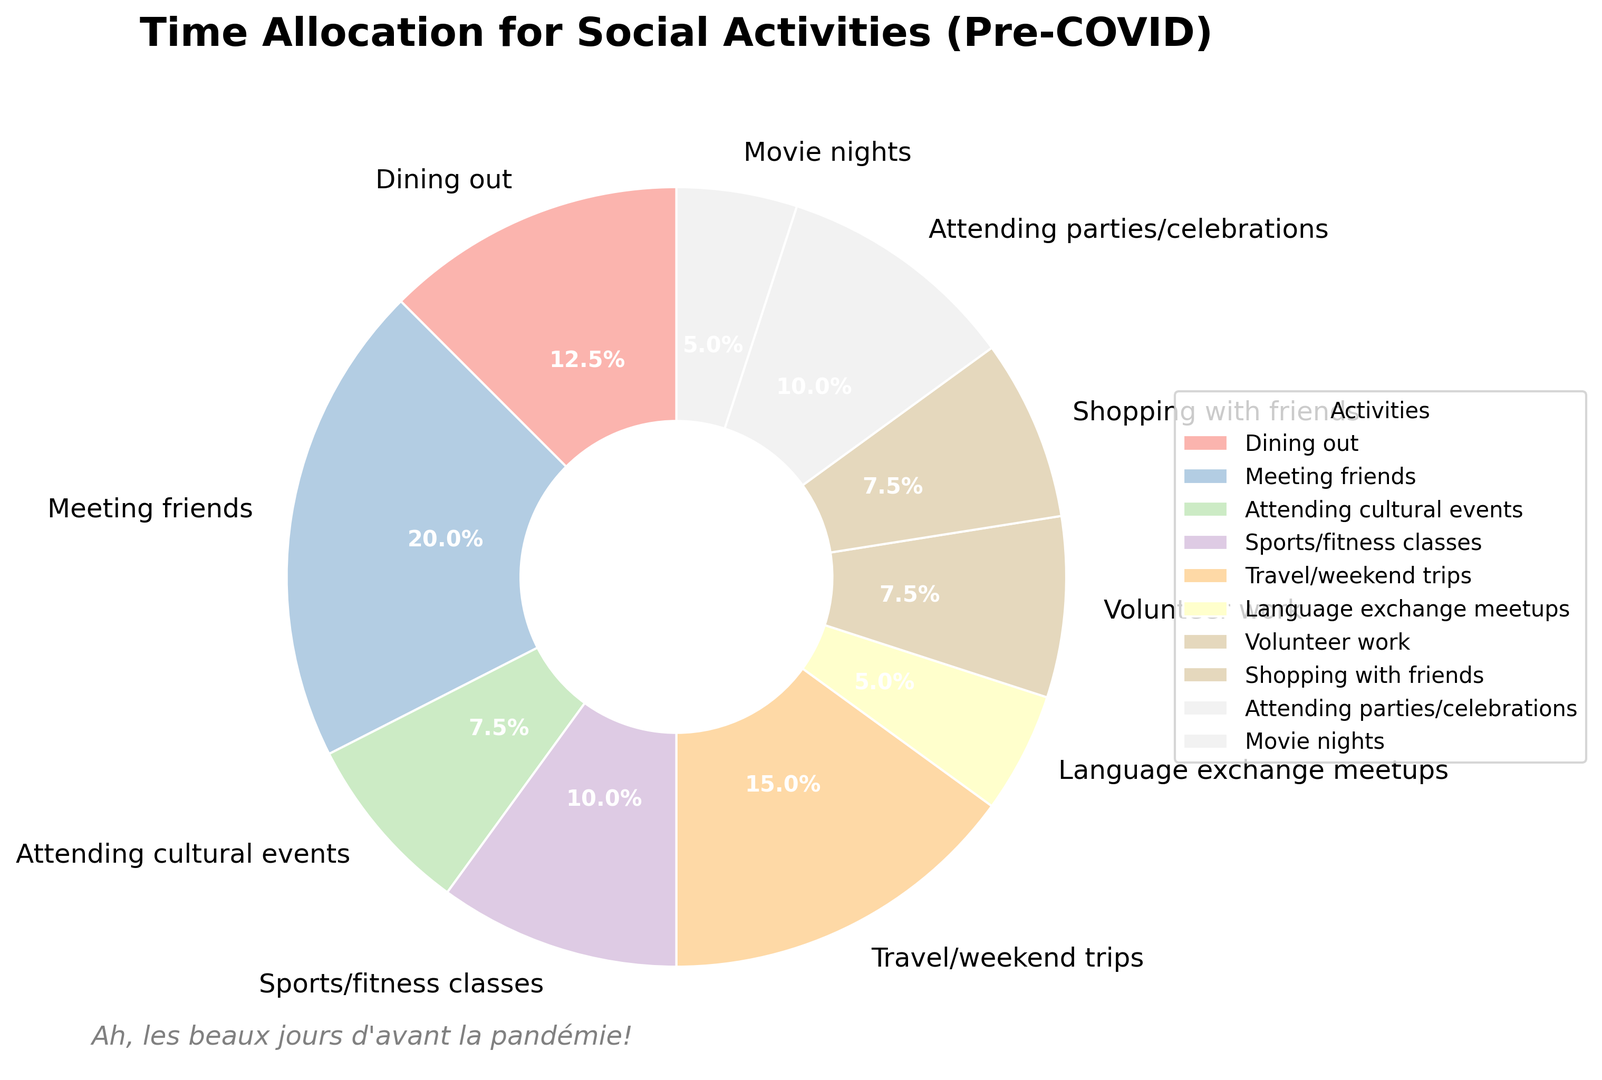Which activity occupies the highest percentage of time? To determine the activity with the highest percentage, locate the segment with the largest area on the pie chart. The segment labeled "Meeting friends" occupies the largest area.
Answer: Meeting friends What is the combined percentage of time spent on attending cultural events and volunteer work? First, find the percentage of each activity from the pie chart. Then add the two percentages together. Attending cultural events and volunteer work are each labeled with their percentages, which are both 6%. Adding these gives 6% + 6% = 12%.
Answer: 12% Is more time allocated to travel/weekend trips or attending parties/celebrations? Compare the percentages shown for travel/weekend trips and attending parties/celebrations. Travel/weekend trips have a larger area and thus represent a higher percentage.
Answer: Travel/weekend trips Which activities take up exactly the same amount of time per week? Look for segments on the pie chart with identical percentages labeled. Attending cultural events, volunteer work, and shopping with friends each have 6% of the pie, indicating they take up the same amount of time.
Answer: Attending cultural events, volunteer work, shopping with friends What is the total number of hours spent on fitness-related and dining-out activities combined? Find the individual hours per week for sports/fitness classes (4 hours) and dining out (5 hours) as labeled in the pie chart. Adding these together gives 4 hours + 5 hours = 9 hours.
Answer: 9 hours What is the difference in time allocation between the activity with the most hours and the least hours? First, identify the activities with the highest and lowest hours. Meeting friends has the highest (8 hours), and language exchange meetups and movie nights have the lowest (2 hours each). Subtract the lowest from the highest: 8 hours - 2 hours = 6 hours.
Answer: 6 hours How much more time is spent on travel/weekend trips compared to language exchange meetups? Identify the hours for travel/weekend trips (6 hours) and language exchange meetups (2 hours). The difference is 6 hours - 2 hours = 4 hours.
Answer: 4 hours 